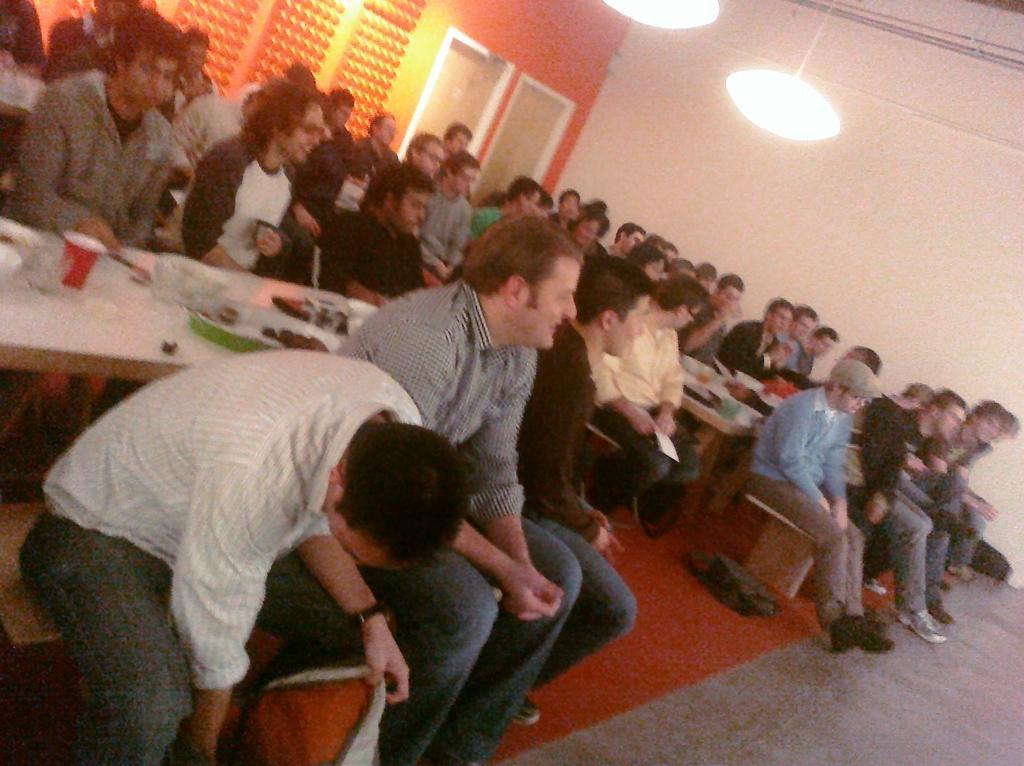Describe this image in one or two sentences. In this image I can see a group of people are sitting on the benches in front of tables on which I can see plates, bowls, glasses and food items. In the background I can see a wall, doors and lights on a rooftop. This image is taken may be in a hall. 